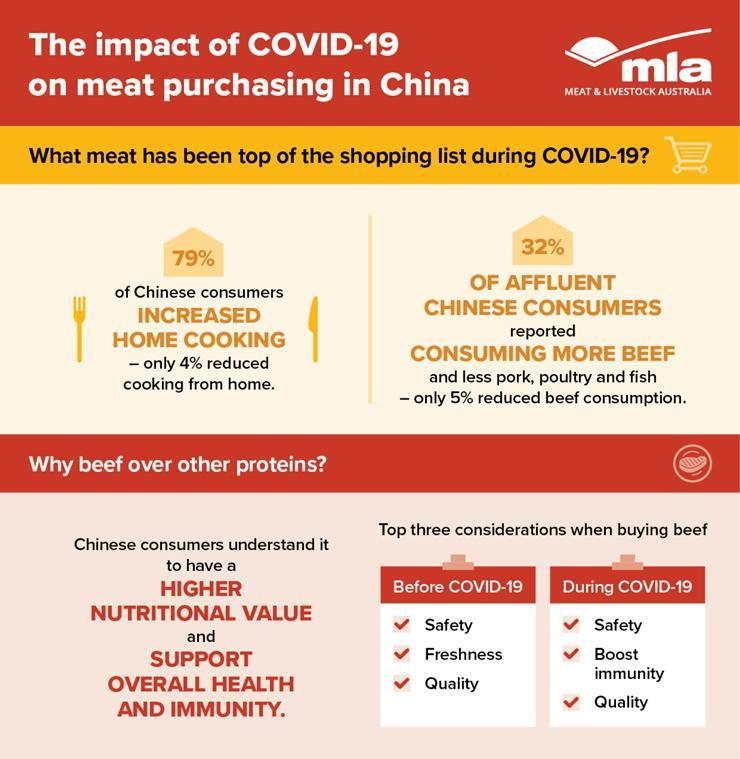Which consideration other than safety remained same before and after COVID-19?
Answer the question with a short phrase. Quality What percent of Chinese did not consume more beef? 68% What meat has been consumed most during COVID-19? BEEF 